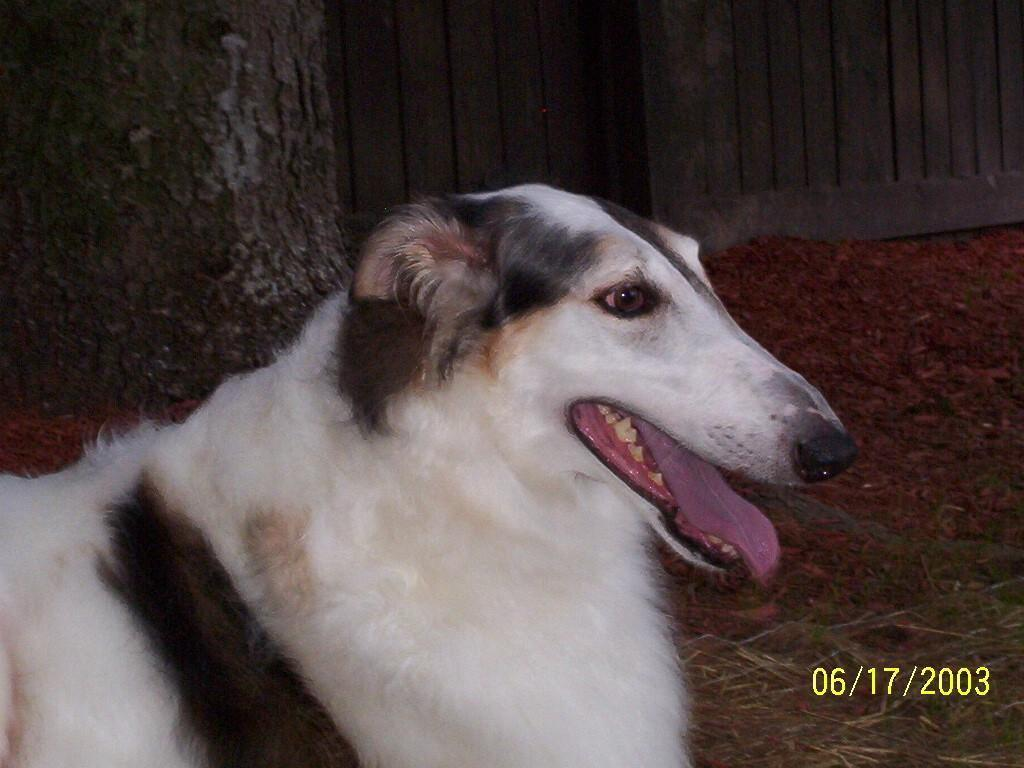What type of animal is in the image? There is a dog in the image. What type of terrain is visible in the image? There is grass in the image. What is the surface on which the dog is standing? The ground is visible in the image. What is the closest object to the dog in the image? There is a tree trunk in the image. What can be seen in the distance in the image? There is a wall in the background of the image. What additional information is provided in the image? The image has a date in the bottom right corner. Which direction is the monkey facing in the image? There is no monkey present in the image. How many times does the dog sneeze in the image? The dog does not sneeze in the image; it is simply standing on the ground. 